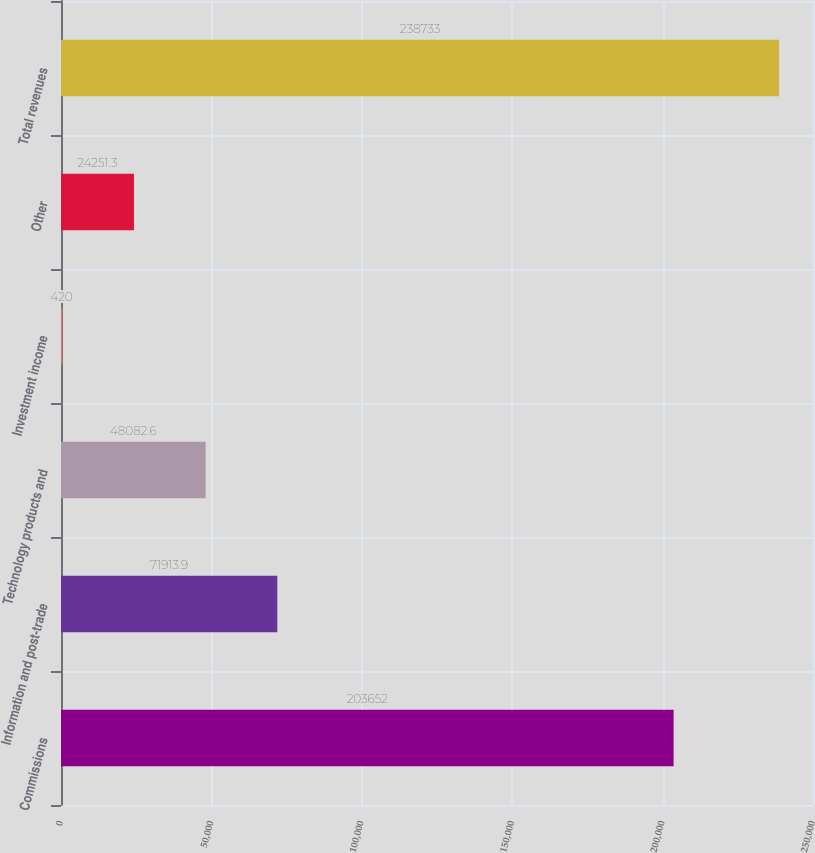<chart> <loc_0><loc_0><loc_500><loc_500><bar_chart><fcel>Commissions<fcel>Information and post-trade<fcel>Technology products and<fcel>Investment income<fcel>Other<fcel>Total revenues<nl><fcel>203652<fcel>71913.9<fcel>48082.6<fcel>420<fcel>24251.3<fcel>238733<nl></chart> 